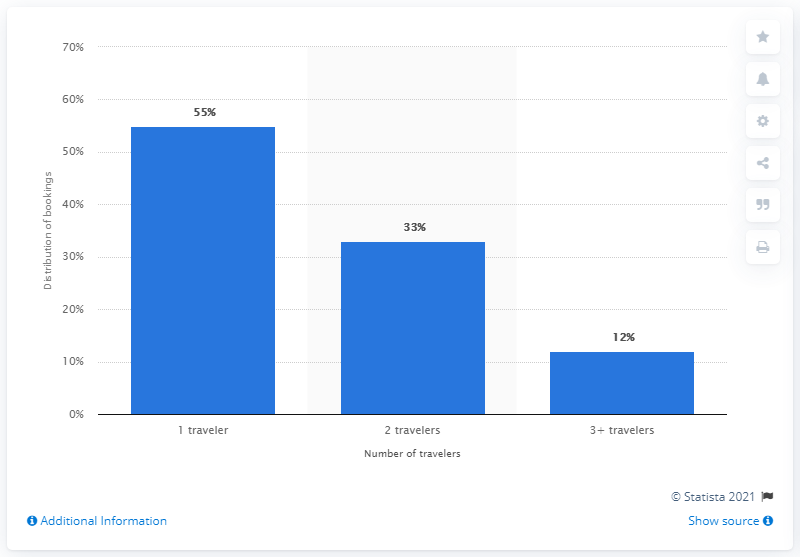Give some essential details in this illustration. In Q4 2015, approximately 33% of all U.S. travel bookings were made for parties of two people. 